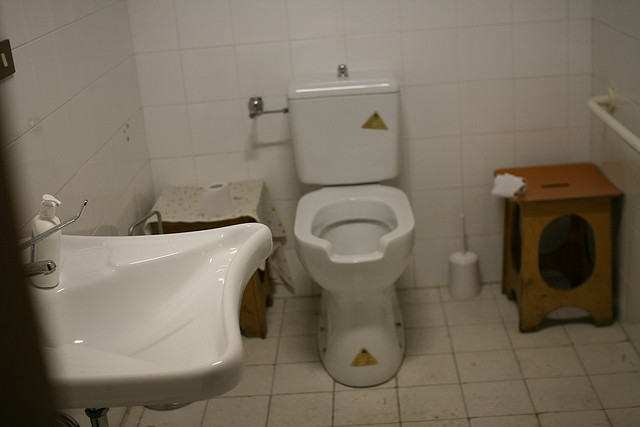What type of room is this? This image shows a small bathroom, typically designed for utilitarian purposes such as personal hygiene activities, which is indicated by the presence of a sink and a toilet. 